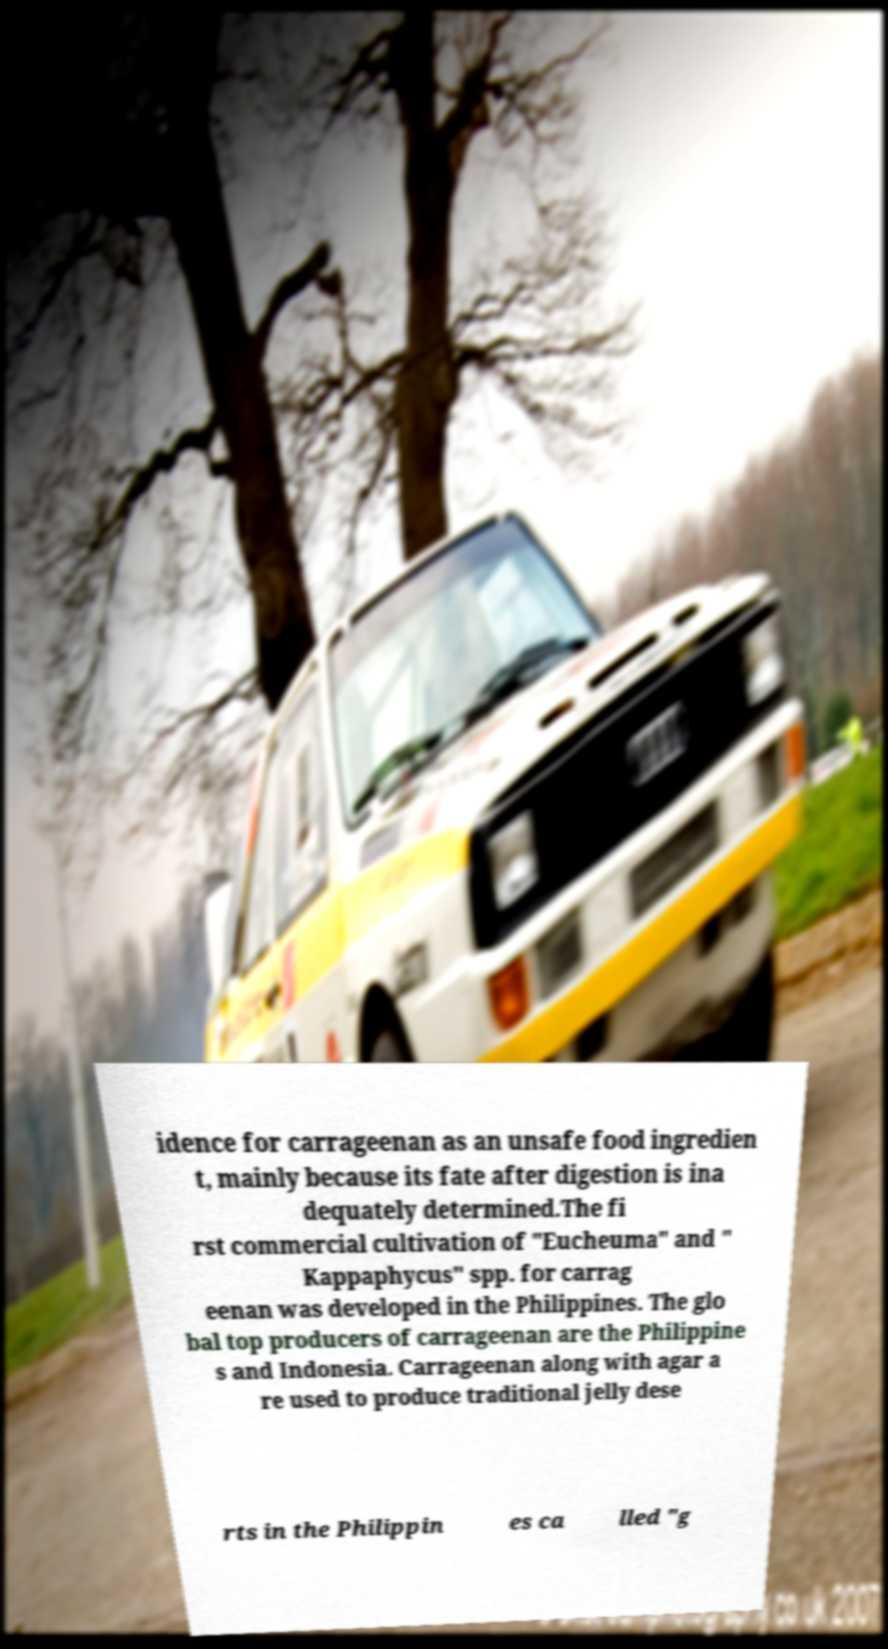For documentation purposes, I need the text within this image transcribed. Could you provide that? idence for carrageenan as an unsafe food ingredien t, mainly because its fate after digestion is ina dequately determined.The fi rst commercial cultivation of "Eucheuma" and " Kappaphycus" spp. for carrag eenan was developed in the Philippines. The glo bal top producers of carrageenan are the Philippine s and Indonesia. Carrageenan along with agar a re used to produce traditional jelly dese rts in the Philippin es ca lled "g 